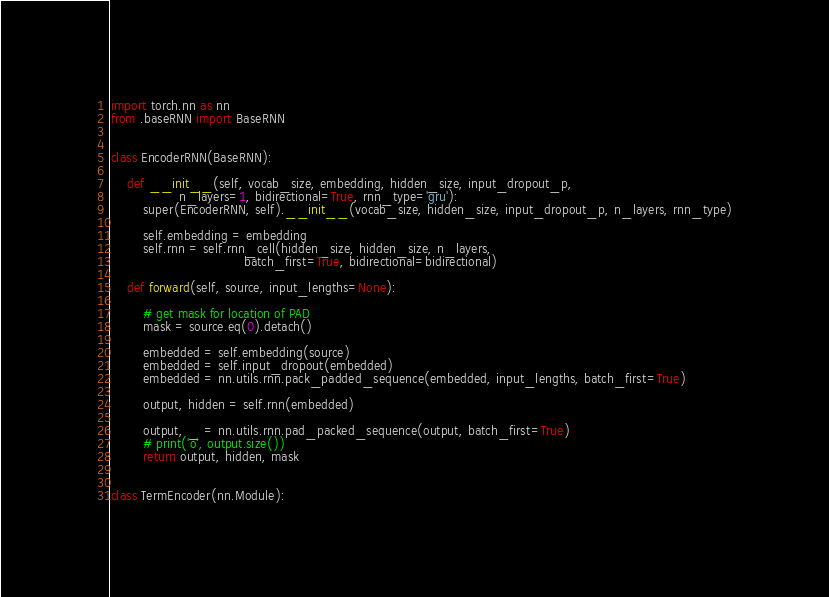Convert code to text. <code><loc_0><loc_0><loc_500><loc_500><_Python_>import torch.nn as nn
from .baseRNN import BaseRNN


class EncoderRNN(BaseRNN):

    def __init__(self, vocab_size, embedding, hidden_size, input_dropout_p,
                 n_layers=1, bidirectional=True, rnn_type='gru'):
        super(EncoderRNN, self).__init__(vocab_size, hidden_size, input_dropout_p, n_layers, rnn_type)

        self.embedding = embedding
        self.rnn = self.rnn_cell(hidden_size, hidden_size, n_layers,
                                 batch_first=True, bidirectional=bidirectional)

    def forward(self, source, input_lengths=None):

        # get mask for location of PAD
        mask = source.eq(0).detach()

        embedded = self.embedding(source)
        embedded = self.input_dropout(embedded)
        embedded = nn.utils.rnn.pack_padded_sequence(embedded, input_lengths, batch_first=True)

        output, hidden = self.rnn(embedded)

        output, _ = nn.utils.rnn.pad_packed_sequence(output, batch_first=True)
        # print('o', output.size())
        return output, hidden, mask


class TermEncoder(nn.Module):
</code> 